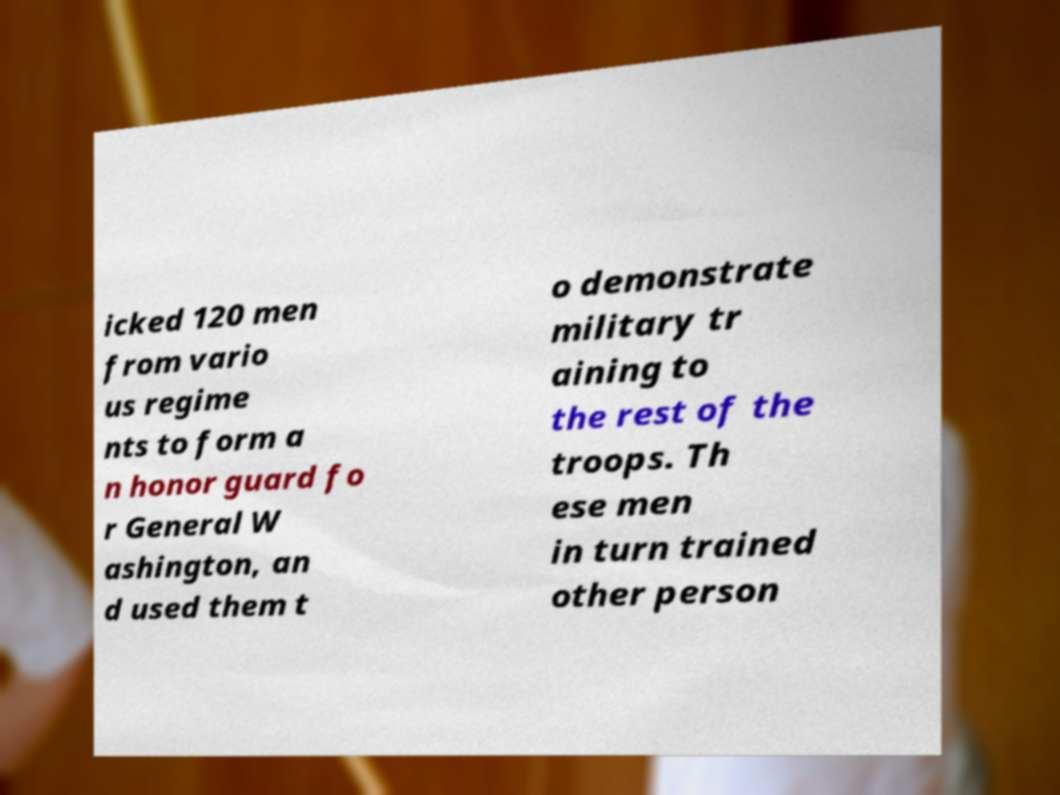What messages or text are displayed in this image? I need them in a readable, typed format. icked 120 men from vario us regime nts to form a n honor guard fo r General W ashington, an d used them t o demonstrate military tr aining to the rest of the troops. Th ese men in turn trained other person 